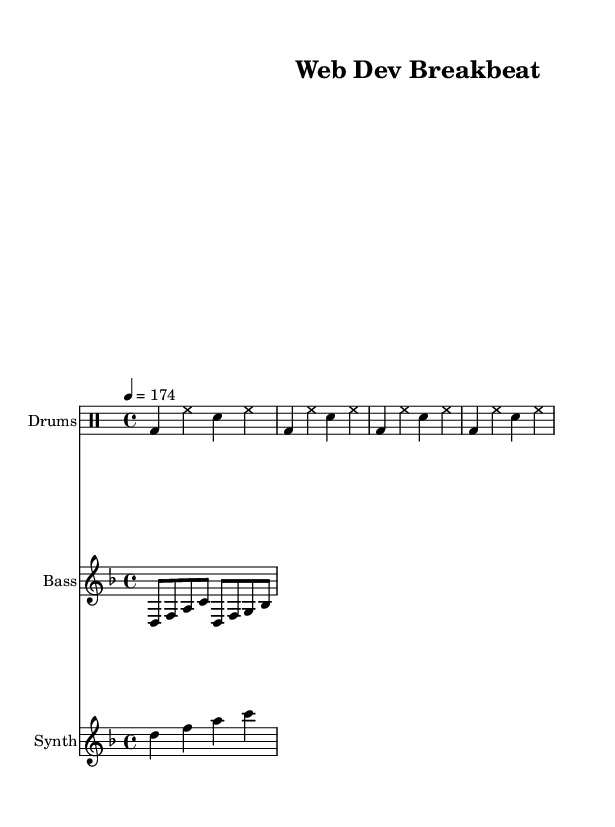What is the key signature of this music? The key signature indicated in the global section shows one flat, which represents D minor.
Answer: D minor What is the time signature used in this sheet music? The time signature marked is 4/4, meaning there are four beats in each measure and the quarter note receives one beat.
Answer: 4/4 What is the tempo of the piece? The tempo marking shows that this piece is to be played at 174 beats per minute, as indicated by the "4 = 174" notation.
Answer: 174 How many measures are shown in the drum part? Counting the drum part notations, there are two groups of four beats making a total of two measures, thus it consists of two measures.
Answer: 2 Which instrument plays the bass line? The staff labeled "Bass" under the second section indicates that the bass line is played on the bass instrument.
Answer: Bass How many different instruments are featured in this score? There are three distinct instrumental parts featured in the score: Drums, Bass, and Synth, as indicated by the separate staves.
Answer: Three What type of music genre is this piece classified as? The overall style and fast-paced beats convey that this track belongs to the dance music genre, particularly characterized by drum and bass elements.
Answer: Dance 